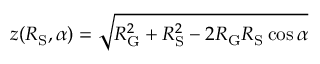<formula> <loc_0><loc_0><loc_500><loc_500>z ( R _ { S } , \alpha ) = \sqrt { R _ { G } ^ { 2 } + R _ { S } ^ { 2 } - 2 R _ { G } R _ { S } \cos \alpha }</formula> 